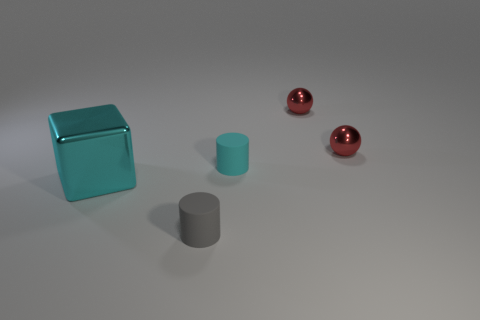Subtract all gray cylinders. How many cylinders are left? 1 Subtract all cubes. How many objects are left? 4 Subtract all purple blocks. How many yellow spheres are left? 0 Add 2 matte things. How many matte things exist? 4 Add 3 tiny gray rubber things. How many objects exist? 8 Subtract 0 gray cubes. How many objects are left? 5 Subtract 1 spheres. How many spheres are left? 1 Subtract all cyan cylinders. Subtract all blue cubes. How many cylinders are left? 1 Subtract all cyan metal things. Subtract all large cyan blocks. How many objects are left? 3 Add 2 tiny red objects. How many tiny red objects are left? 4 